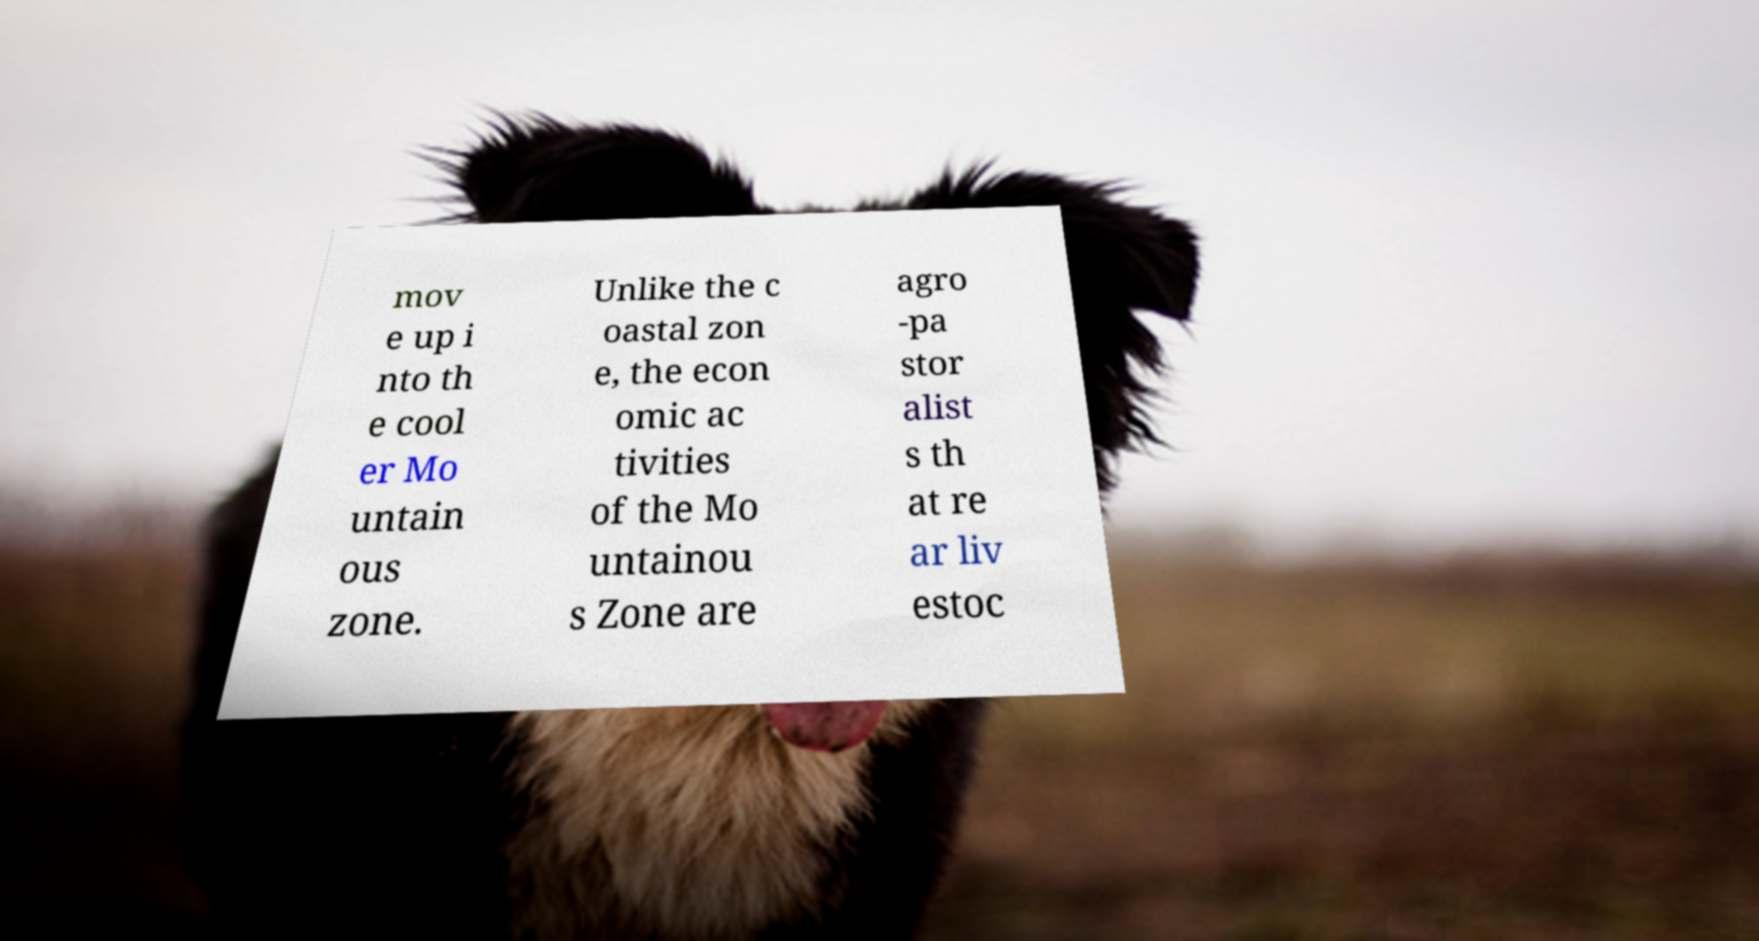There's text embedded in this image that I need extracted. Can you transcribe it verbatim? mov e up i nto th e cool er Mo untain ous zone. Unlike the c oastal zon e, the econ omic ac tivities of the Mo untainou s Zone are agro -pa stor alist s th at re ar liv estoc 